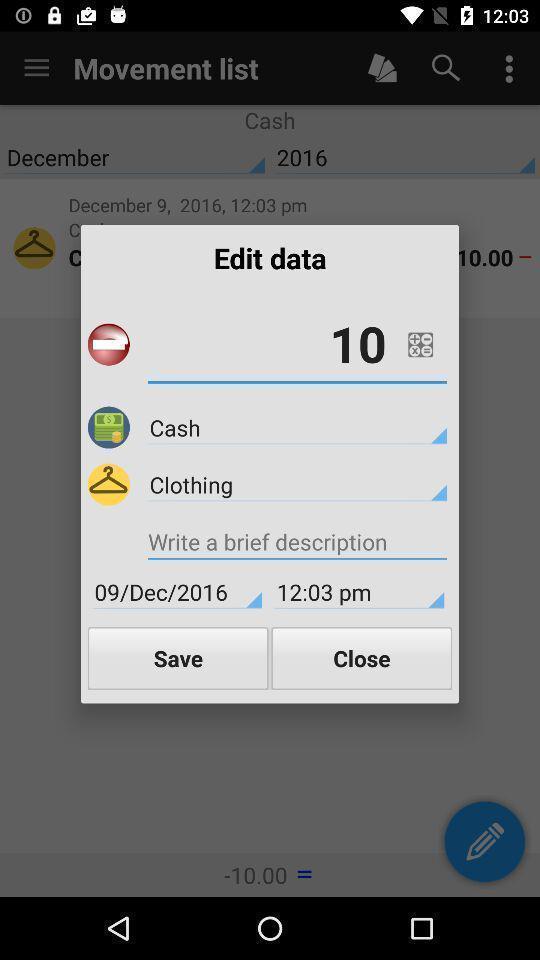Explain the elements present in this screenshot. Popup showing fields to enter. 